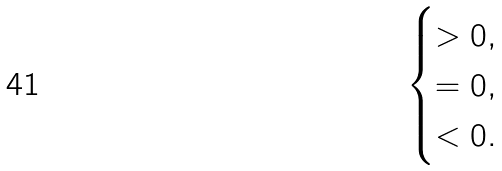Convert formula to latex. <formula><loc_0><loc_0><loc_500><loc_500>\begin{cases} > 0 , \\ = 0 , \\ < 0 . \\ \end{cases}</formula> 